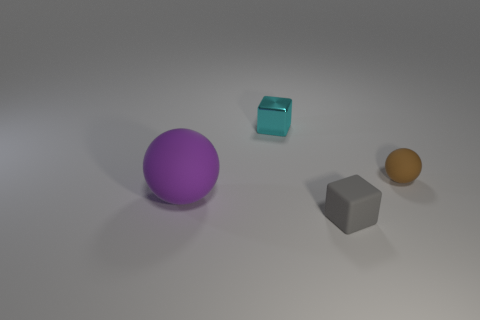There is a thing that is both on the right side of the cyan metal cube and behind the rubber cube; what color is it? In the image provided, there is no object that is both on the right side of the cyan metal cube and behind the rubber cube simultaneously. The objects in the image include a purple sphere, a cyan cube, a grey cube, and an orange sphere. 